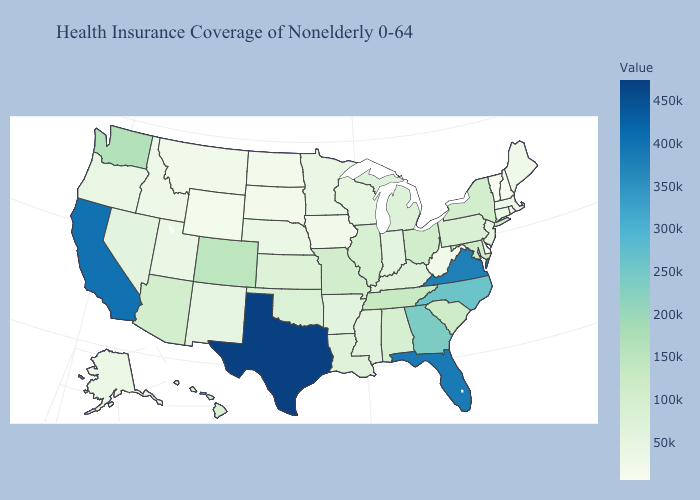Does Wyoming have the lowest value in the West?
Give a very brief answer. Yes. Does the map have missing data?
Concise answer only. No. Does South Carolina have a lower value than North Carolina?
Be succinct. Yes. Which states have the lowest value in the West?
Answer briefly. Wyoming. Is the legend a continuous bar?
Short answer required. Yes. Which states have the lowest value in the South?
Short answer required. Delaware. 